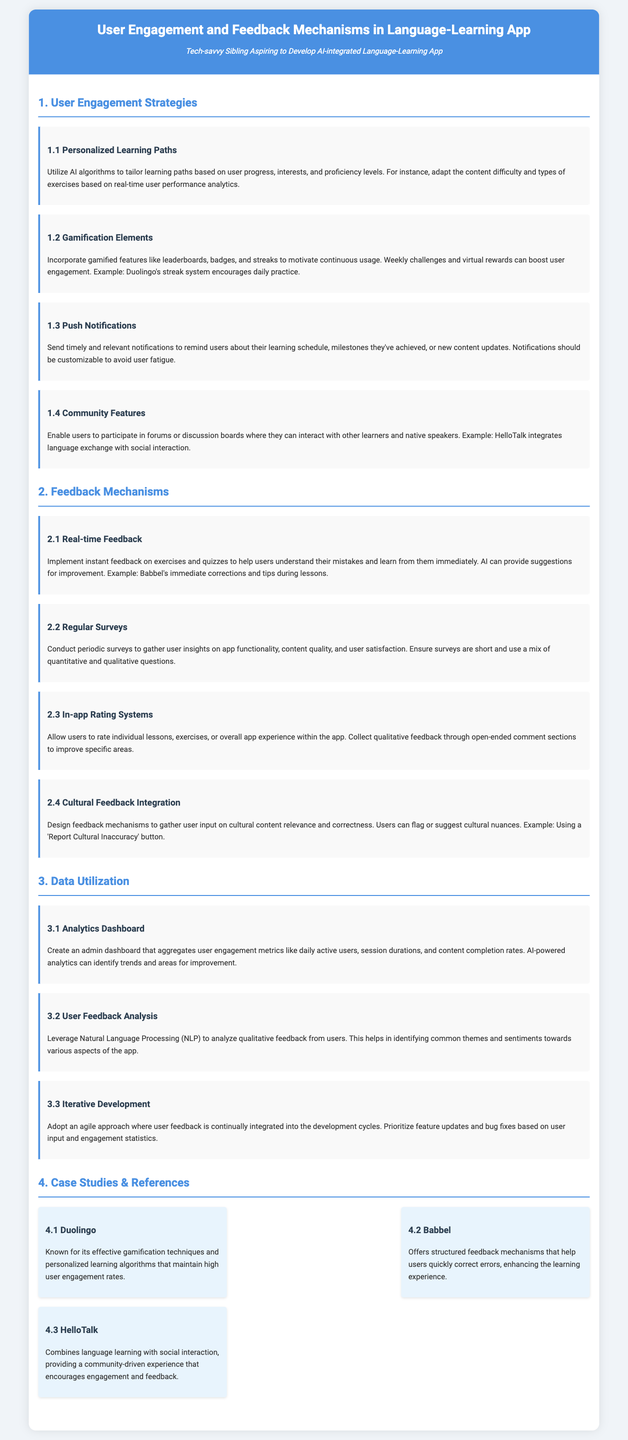What are the user engagement strategies? The document lists multiple strategies including personalized learning paths, gamification elements, push notifications, and community features.
Answer: Personalized learning paths, gamification elements, push notifications, community features What does the subsection "2.1" focus on? This subsection discusses the importance of providing instant feedback on exercises and quizzes to help users learn from their mistakes immediately.
Answer: Real-time Feedback Which case study emphasizes gamification techniques? The document states that Duolingo is known for its effective gamification techniques and personalized learning algorithms.
Answer: Duolingo How often should regular surveys be conducted? Although the document does not specify frequency, it indicates that periodic surveys should gather user insights.
Answer: Periodically What technology is suggested for analyzing qualitative feedback? The document mentions leveraging Natural Language Processing (NLP) for analyzing qualitative feedback from users.
Answer: Natural Language Processing How should user feedback influence app development? The document states that user feedback should be continuously integrated into development cycles and prioritized for updates.
Answer: Iterative Development What cultural content feature is suggested in the feedback mechanisms? Users are encouraged to flag or suggest relevant cultural nuances, identified by a 'Report Cultural Inaccuracy' button.
Answer: Report Cultural Inaccuracy What type of engagement metrics can be found in the analytics dashboard? The dashboard aggregates user engagement metrics like daily active users, session durations, and content completion rates.
Answer: Daily active users, session durations, content completion rates What is the purpose of push notifications? The document indicates that push notifications remind users about their learning schedule, milestones, or new content.
Answer: Remind users about learning schedule, milestones, new content 